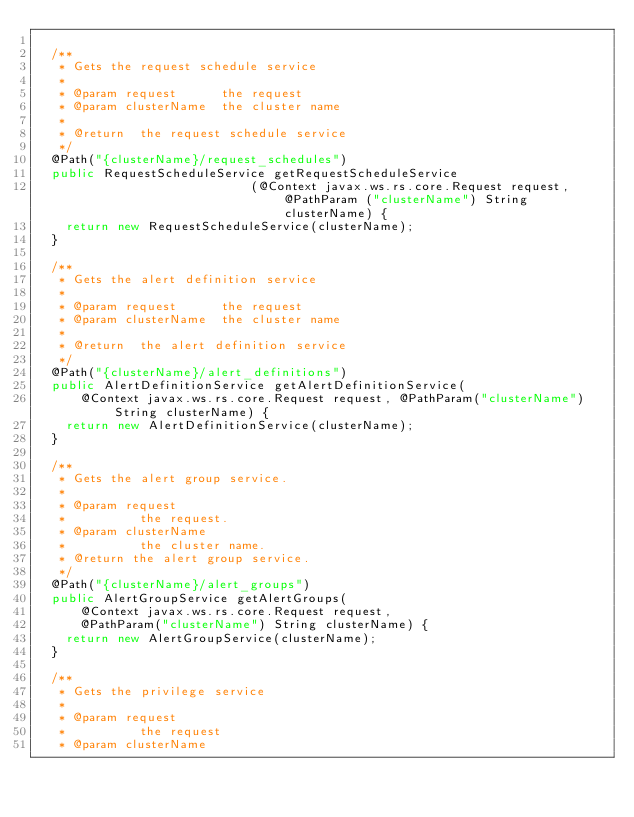<code> <loc_0><loc_0><loc_500><loc_500><_Java_>
  /**
   * Gets the request schedule service
   *
   * @param request      the request
   * @param clusterName  the cluster name
   *
   * @return  the request schedule service
   */
  @Path("{clusterName}/request_schedules")
  public RequestScheduleService getRequestScheduleService
                             (@Context javax.ws.rs.core.Request request, @PathParam ("clusterName") String clusterName) {
    return new RequestScheduleService(clusterName);
  }

  /**
   * Gets the alert definition service
   *
   * @param request      the request
   * @param clusterName  the cluster name
   *
   * @return  the alert definition service
   */
  @Path("{clusterName}/alert_definitions")
  public AlertDefinitionService getAlertDefinitionService(
      @Context javax.ws.rs.core.Request request, @PathParam("clusterName") String clusterName) {
    return new AlertDefinitionService(clusterName);
  }

  /**
   * Gets the alert group service.
   *
   * @param request
   *          the request.
   * @param clusterName
   *          the cluster name.
   * @return the alert group service.
   */
  @Path("{clusterName}/alert_groups")
  public AlertGroupService getAlertGroups(
      @Context javax.ws.rs.core.Request request,
      @PathParam("clusterName") String clusterName) {
    return new AlertGroupService(clusterName);
  }

  /**
   * Gets the privilege service
   *
   * @param request
   *          the request
   * @param clusterName</code> 